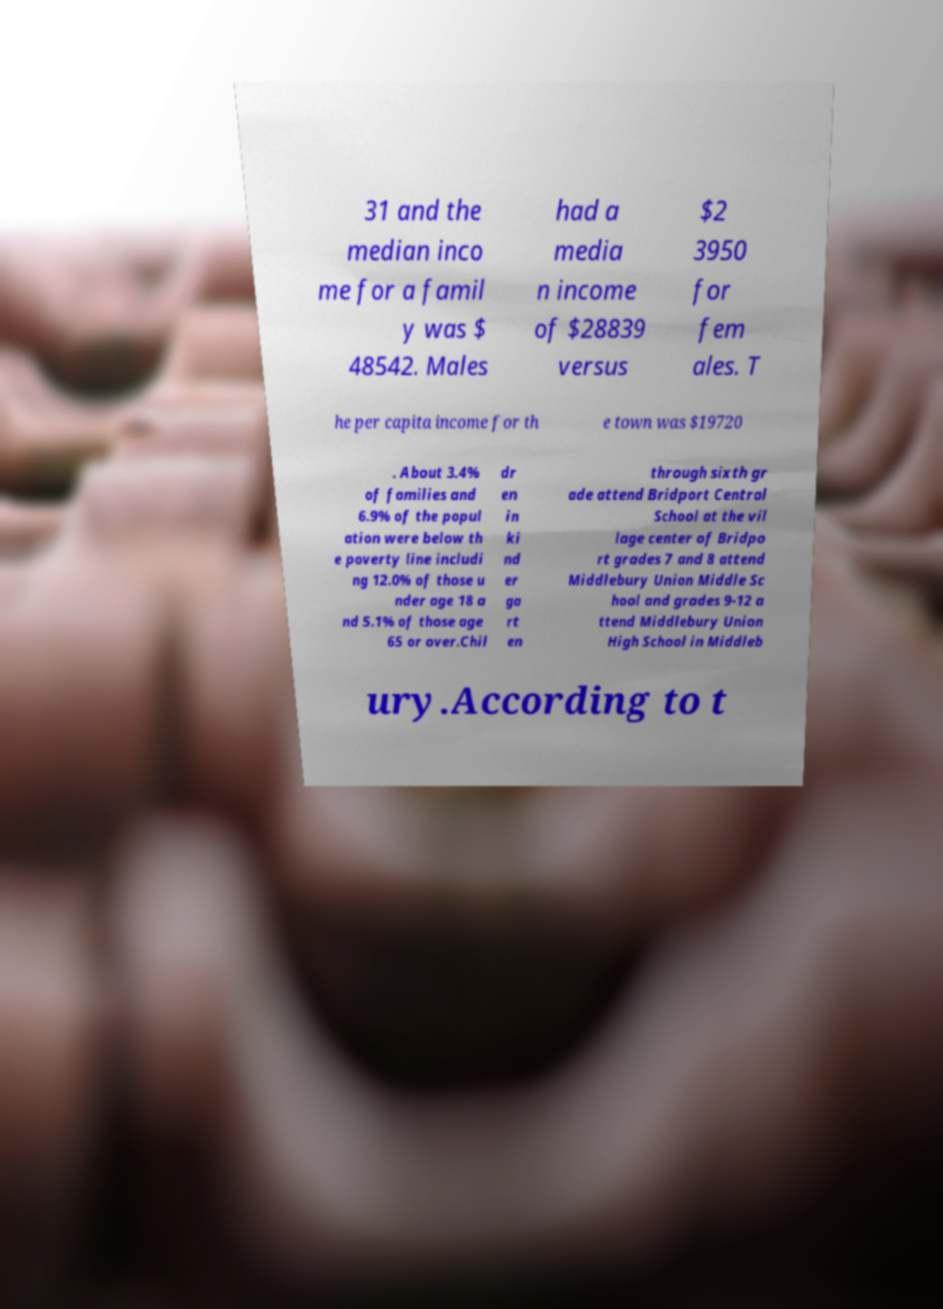Could you assist in decoding the text presented in this image and type it out clearly? 31 and the median inco me for a famil y was $ 48542. Males had a media n income of $28839 versus $2 3950 for fem ales. T he per capita income for th e town was $19720 . About 3.4% of families and 6.9% of the popul ation were below th e poverty line includi ng 12.0% of those u nder age 18 a nd 5.1% of those age 65 or over.Chil dr en in ki nd er ga rt en through sixth gr ade attend Bridport Central School at the vil lage center of Bridpo rt grades 7 and 8 attend Middlebury Union Middle Sc hool and grades 9-12 a ttend Middlebury Union High School in Middleb ury.According to t 